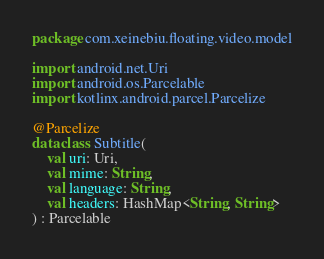Convert code to text. <code><loc_0><loc_0><loc_500><loc_500><_Kotlin_>package com.xeinebiu.floating.video.model

import android.net.Uri
import android.os.Parcelable
import kotlinx.android.parcel.Parcelize

@Parcelize
data class Subtitle(
    val uri: Uri,
    val mime: String,
    val language: String,
    val headers: HashMap<String, String>
) : Parcelable
</code> 